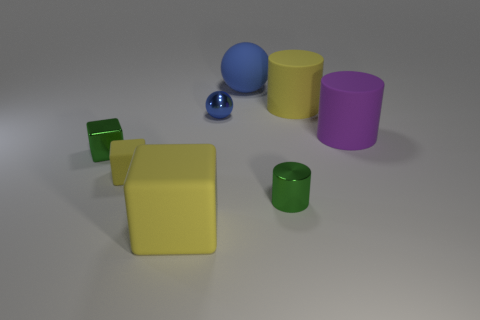There is a large yellow thing on the right side of the tiny metallic cylinder; what shape is it?
Provide a short and direct response. Cylinder. Are there any rubber cylinders to the left of the metallic block?
Provide a succinct answer. No. There is a tiny ball that is the same material as the green cube; what color is it?
Your response must be concise. Blue. There is a matte block behind the big block; does it have the same color as the big thing that is to the left of the tiny blue ball?
Offer a terse response. Yes. What number of cylinders are either green objects or small yellow things?
Offer a very short reply. 1. Is the number of small rubber things that are in front of the tiny metal cylinder the same as the number of objects?
Give a very brief answer. No. The big object in front of the shiny thing left of the big yellow object in front of the small shiny cylinder is made of what material?
Your response must be concise. Rubber. What is the material of the other big sphere that is the same color as the metal sphere?
Give a very brief answer. Rubber. What number of things are big yellow things on the right side of the blue metallic ball or large brown rubber cylinders?
Make the answer very short. 1. How many things are purple cylinders or rubber things that are in front of the big purple object?
Provide a succinct answer. 3. 